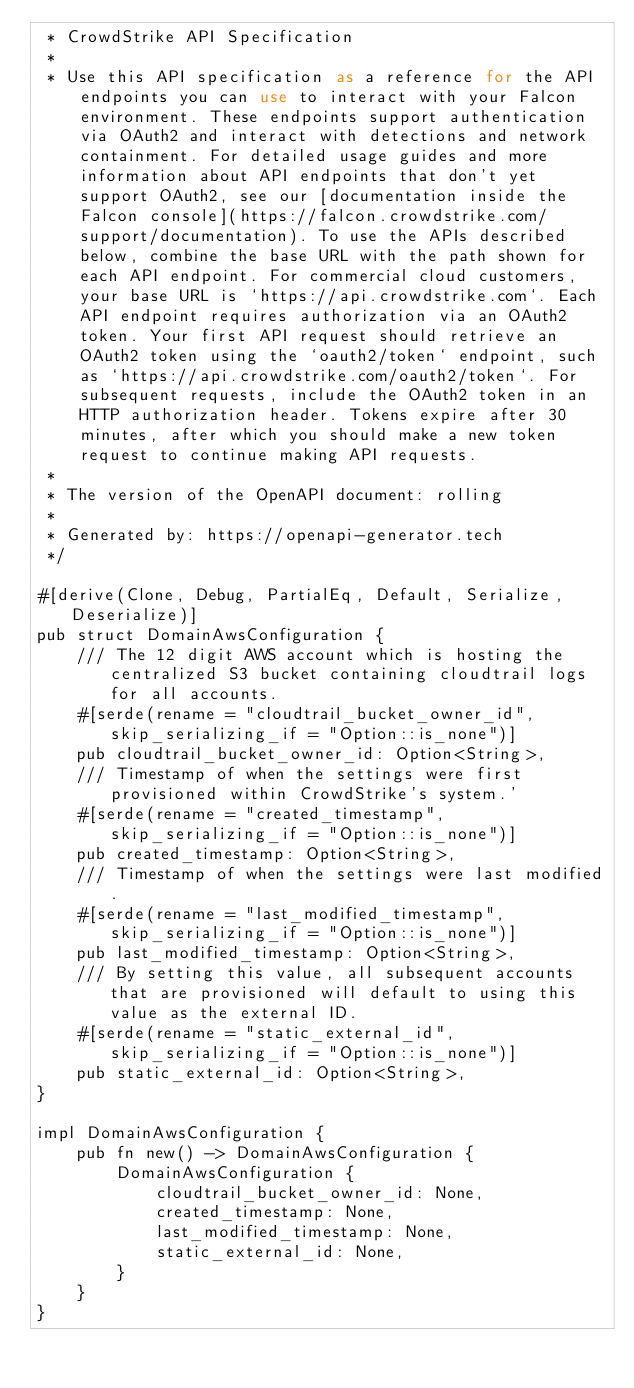Convert code to text. <code><loc_0><loc_0><loc_500><loc_500><_Rust_> * CrowdStrike API Specification
 *
 * Use this API specification as a reference for the API endpoints you can use to interact with your Falcon environment. These endpoints support authentication via OAuth2 and interact with detections and network containment. For detailed usage guides and more information about API endpoints that don't yet support OAuth2, see our [documentation inside the Falcon console](https://falcon.crowdstrike.com/support/documentation). To use the APIs described below, combine the base URL with the path shown for each API endpoint. For commercial cloud customers, your base URL is `https://api.crowdstrike.com`. Each API endpoint requires authorization via an OAuth2 token. Your first API request should retrieve an OAuth2 token using the `oauth2/token` endpoint, such as `https://api.crowdstrike.com/oauth2/token`. For subsequent requests, include the OAuth2 token in an HTTP authorization header. Tokens expire after 30 minutes, after which you should make a new token request to continue making API requests.
 *
 * The version of the OpenAPI document: rolling
 *
 * Generated by: https://openapi-generator.tech
 */

#[derive(Clone, Debug, PartialEq, Default, Serialize, Deserialize)]
pub struct DomainAwsConfiguration {
    /// The 12 digit AWS account which is hosting the centralized S3 bucket containing cloudtrail logs for all accounts.
    #[serde(rename = "cloudtrail_bucket_owner_id", skip_serializing_if = "Option::is_none")]
    pub cloudtrail_bucket_owner_id: Option<String>,
    /// Timestamp of when the settings were first provisioned within CrowdStrike's system.'
    #[serde(rename = "created_timestamp", skip_serializing_if = "Option::is_none")]
    pub created_timestamp: Option<String>,
    /// Timestamp of when the settings were last modified.
    #[serde(rename = "last_modified_timestamp", skip_serializing_if = "Option::is_none")]
    pub last_modified_timestamp: Option<String>,
    /// By setting this value, all subsequent accounts that are provisioned will default to using this value as the external ID.
    #[serde(rename = "static_external_id", skip_serializing_if = "Option::is_none")]
    pub static_external_id: Option<String>,
}

impl DomainAwsConfiguration {
    pub fn new() -> DomainAwsConfiguration {
        DomainAwsConfiguration {
            cloudtrail_bucket_owner_id: None,
            created_timestamp: None,
            last_modified_timestamp: None,
            static_external_id: None,
        }
    }
}
</code> 